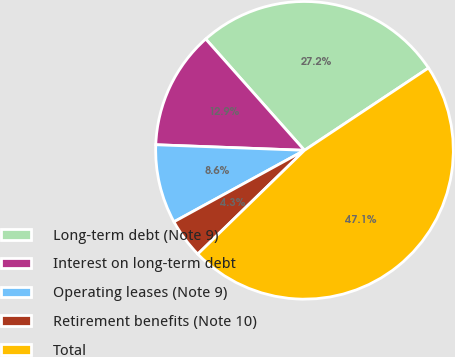Convert chart. <chart><loc_0><loc_0><loc_500><loc_500><pie_chart><fcel>Long-term debt (Note 9)<fcel>Interest on long-term debt<fcel>Operating leases (Note 9)<fcel>Retirement benefits (Note 10)<fcel>Total<nl><fcel>27.22%<fcel>12.85%<fcel>8.57%<fcel>4.3%<fcel>47.05%<nl></chart> 